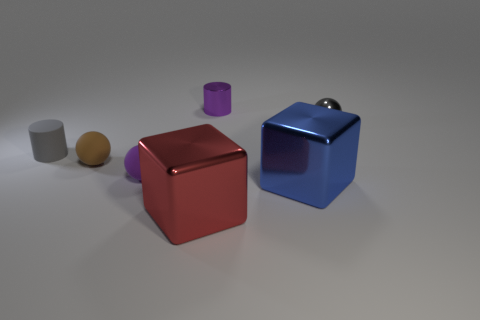Subtract all tiny purple spheres. How many spheres are left? 2 Add 2 blue shiny blocks. How many objects exist? 9 Subtract all yellow balls. Subtract all blue cubes. How many balls are left? 3 Add 5 purple matte spheres. How many purple matte spheres are left? 6 Add 4 purple shiny things. How many purple shiny things exist? 5 Subtract 0 yellow balls. How many objects are left? 7 Subtract all cylinders. How many objects are left? 5 Subtract all big red metal objects. Subtract all small brown balls. How many objects are left? 5 